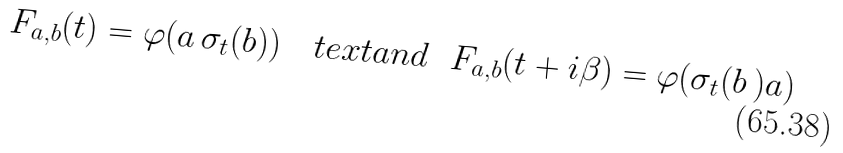<formula> <loc_0><loc_0><loc_500><loc_500>F _ { a , b } ( t ) = \varphi ( a \, \sigma _ { t } ( b ) ) \quad t e x t { a n d } \ \ F _ { a , b } ( t + i \beta ) = \varphi ( \sigma _ { t } ( b \, ) a )</formula> 